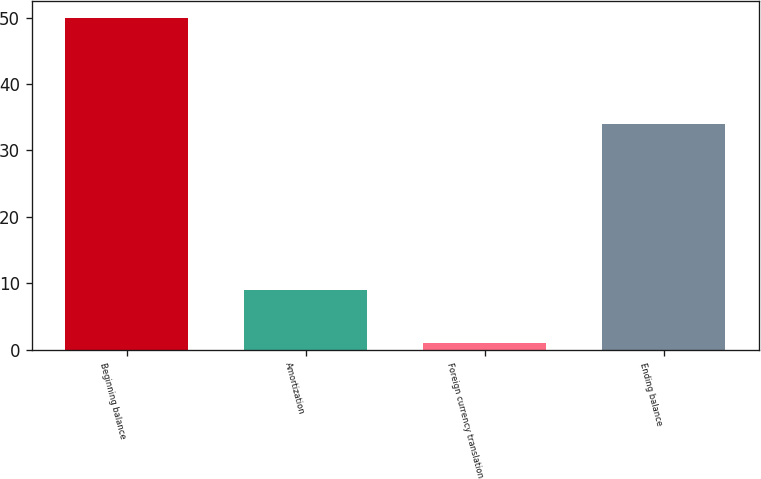Convert chart. <chart><loc_0><loc_0><loc_500><loc_500><bar_chart><fcel>Beginning balance<fcel>Amortization<fcel>Foreign currency translation<fcel>Ending balance<nl><fcel>50<fcel>9<fcel>1<fcel>34<nl></chart> 